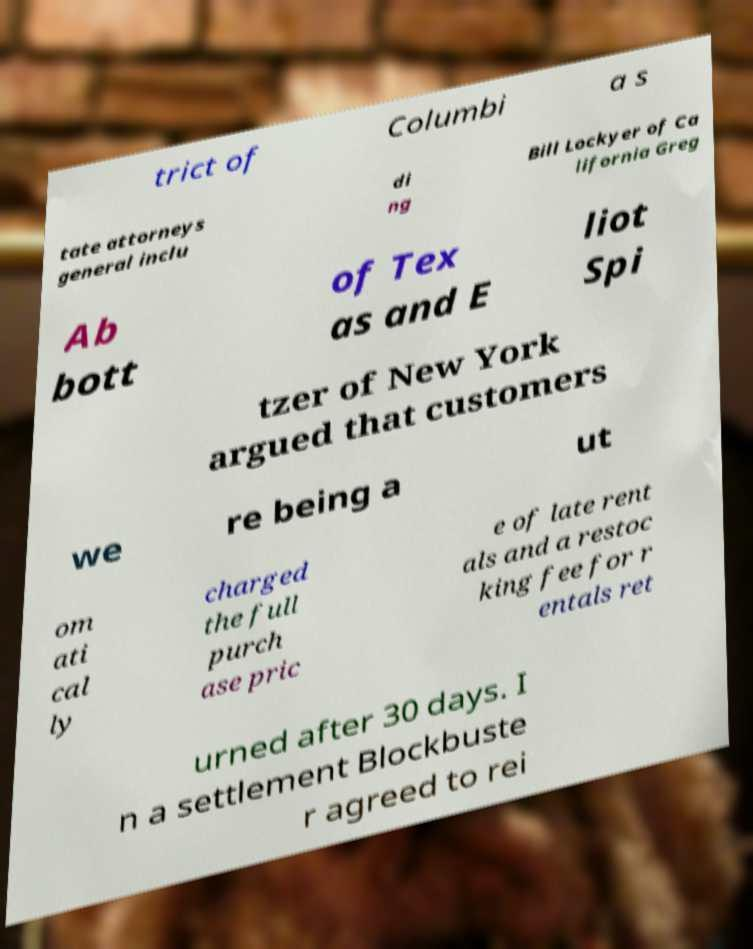Could you extract and type out the text from this image? trict of Columbi a s tate attorneys general inclu di ng Bill Lockyer of Ca lifornia Greg Ab bott of Tex as and E liot Spi tzer of New York argued that customers we re being a ut om ati cal ly charged the full purch ase pric e of late rent als and a restoc king fee for r entals ret urned after 30 days. I n a settlement Blockbuste r agreed to rei 